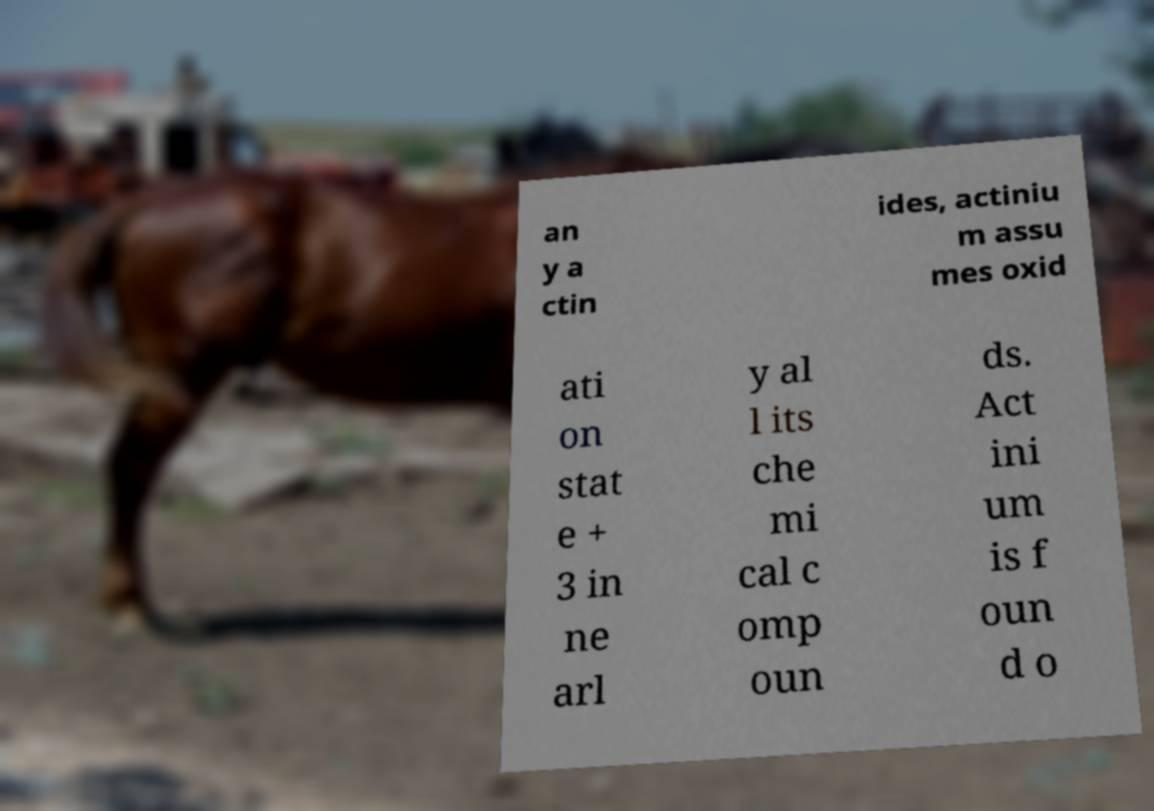Can you read and provide the text displayed in the image?This photo seems to have some interesting text. Can you extract and type it out for me? an y a ctin ides, actiniu m assu mes oxid ati on stat e + 3 in ne arl y al l its che mi cal c omp oun ds. Act ini um is f oun d o 